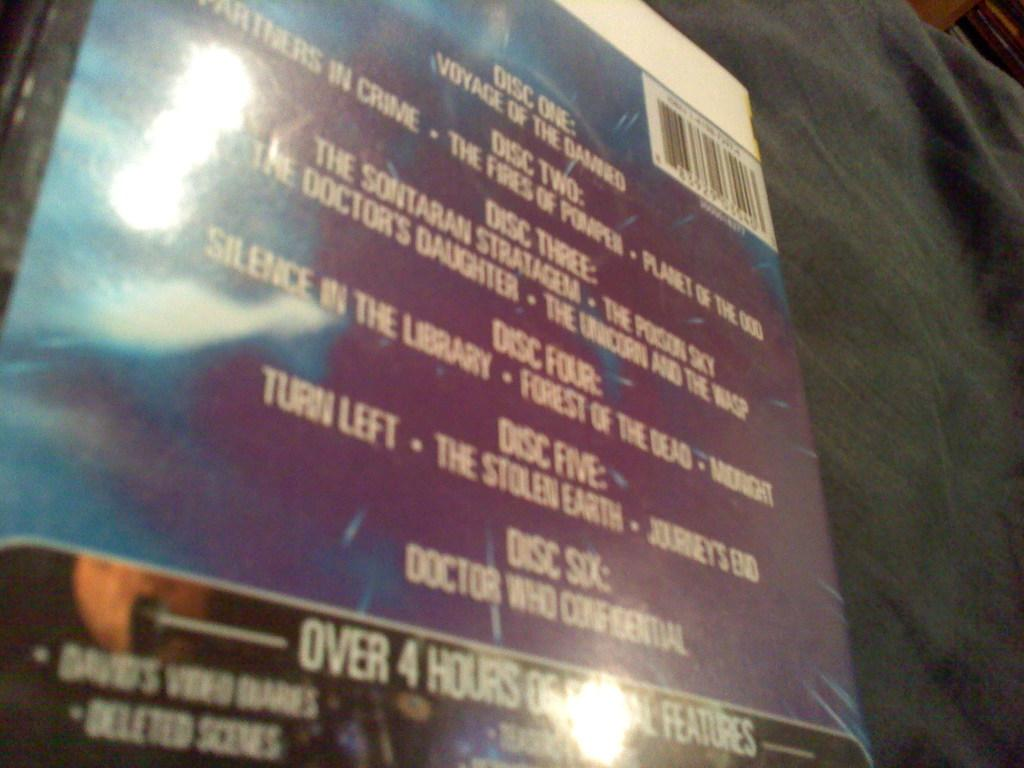<image>
Describe the image concisely. The back of a DVD set shows that it has six discs. 